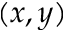Convert formula to latex. <formula><loc_0><loc_0><loc_500><loc_500>( x , y )</formula> 